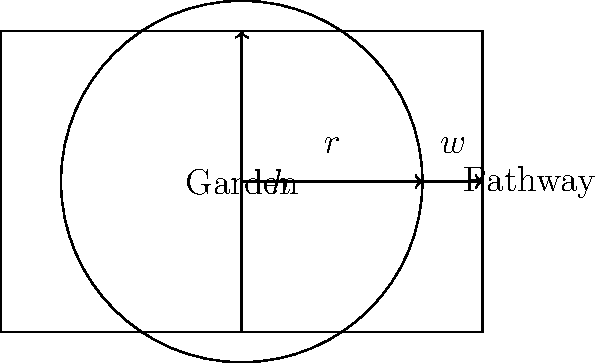Your family decides to create a circular garden with a rectangular pathway around it. The garden has a radius of 3 meters, and the pathway is 1 meter wide. If the total length of the rectangular area (including the garden and pathway) is 5 meters, what is the total area of the garden and pathway combined? Let's approach this step-by-step:

1. Calculate the area of the circular garden:
   Area of circle = $\pi r^2$
   $A_{garden} = \pi \cdot 3^2 = 9\pi$ square meters

2. Calculate the width of the entire rectangular area:
   Total width = Diameter of garden + 2 × Pathway width
   $w_{total} = 2r + 2w = 2 \cdot 3 + 2 \cdot 1 = 8$ meters

3. We're given that the total length is 5 meters, so now we can calculate the area of the rectangle:
   Area of rectangle = Length × Width
   $A_{total} = 5 \cdot 8 = 40$ square meters

4. The total area we're looking for is the area of the rectangle, which includes both the garden and the pathway.

Therefore, the total area of the garden and pathway combined is 40 square meters.
Answer: 40 square meters 